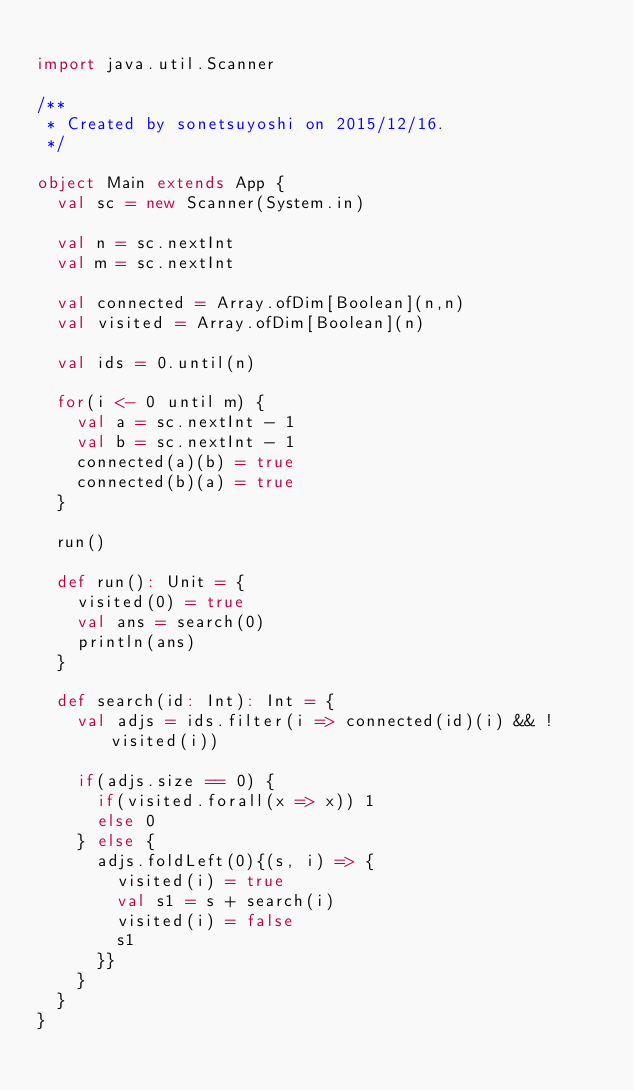Convert code to text. <code><loc_0><loc_0><loc_500><loc_500><_Scala_>
import java.util.Scanner

/**
 * Created by sonetsuyoshi on 2015/12/16.
 */

object Main extends App {
  val sc = new Scanner(System.in)

  val n = sc.nextInt
  val m = sc.nextInt

  val connected = Array.ofDim[Boolean](n,n)
  val visited = Array.ofDim[Boolean](n)

  val ids = 0.until(n)

  for(i <- 0 until m) {
    val a = sc.nextInt - 1
    val b = sc.nextInt - 1
    connected(a)(b) = true
    connected(b)(a) = true
  }

  run()

  def run(): Unit = {
    visited(0) = true
    val ans = search(0)
    println(ans)
  }

  def search(id: Int): Int = {
    val adjs = ids.filter(i => connected(id)(i) && !visited(i))

    if(adjs.size == 0) {
      if(visited.forall(x => x)) 1
      else 0
    } else {
      adjs.foldLeft(0){(s, i) => {
        visited(i) = true
        val s1 = s + search(i)
        visited(i) = false
        s1
      }}
    }
  }
}
</code> 